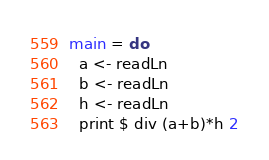Convert code to text. <code><loc_0><loc_0><loc_500><loc_500><_Haskell_>main = do
  a <- readLn
  b <- readLn
  h <- readLn
  print $ div (a+b)*h 2</code> 